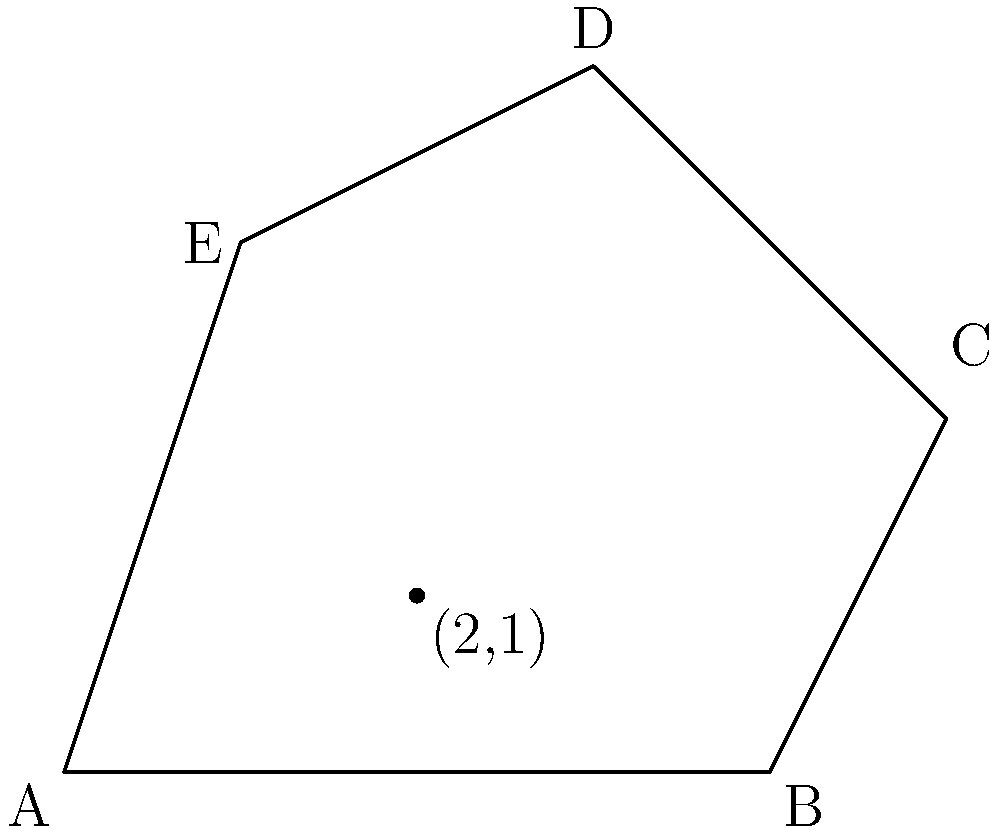Consider the irregular polygon ABCDE, which resembles the shape of Romania's borders. Given that point (2,1) is inside the polygon, use the shoelace formula to calculate the area of this polygon. How does this area compare to the actual size of Romania (238,397 km²)? To solve this problem, we'll use the shoelace formula and follow these steps:

1) The shoelace formula for the area of a polygon with vertices $(x_1, y_1), (x_2, y_2), ..., (x_n, y_n)$ is:

   $$A = \frac{1}{2}|(x_1y_2 + x_2y_3 + ... + x_ny_1) - (y_1x_2 + y_2x_3 + ... + y_nx_1)|$$

2) For our polygon ABCDE, we have the following coordinates:
   A(0,0), B(4,0), C(5,2), D(3,4), E(1,3)

3) Applying the formula:

   $$A = \frac{1}{2}|(0\cdot0 + 4\cdot2 + 5\cdot4 + 3\cdot3 + 1\cdot0) - (0\cdot4 + 0\cdot5 + 2\cdot3 + 4\cdot1 + 3\cdot0)|$$

4) Simplifying:

   $$A = \frac{1}{2}|(0 + 8 + 20 + 9 + 0) - (0 + 0 + 6 + 4 + 0)|$$
   $$A = \frac{1}{2}|37 - 10| = \frac{1}{2} \cdot 27 = 13.5$$

5) Therefore, the area of the polygon is 13.5 square units.

6) To compare this to Romania's actual size, we need to establish a scale. Let's assume 1 unit in our polygon represents 100 km.

7) In this case, the area of our polygon would represent:
   $$13.5 \cdot 100^2 = 135,000 \text{ km}^2$$

8) Comparing to Romania's actual size:
   $$\frac{135,000}{238,397} \approx 0.5662 \text{ or about } 56.62\%$$

This polygon represents approximately 56.62% of Romania's actual size, which is a reasonable approximation for a simplified border representation.
Answer: 13.5 square units, ~56.62% of Romania's actual size 